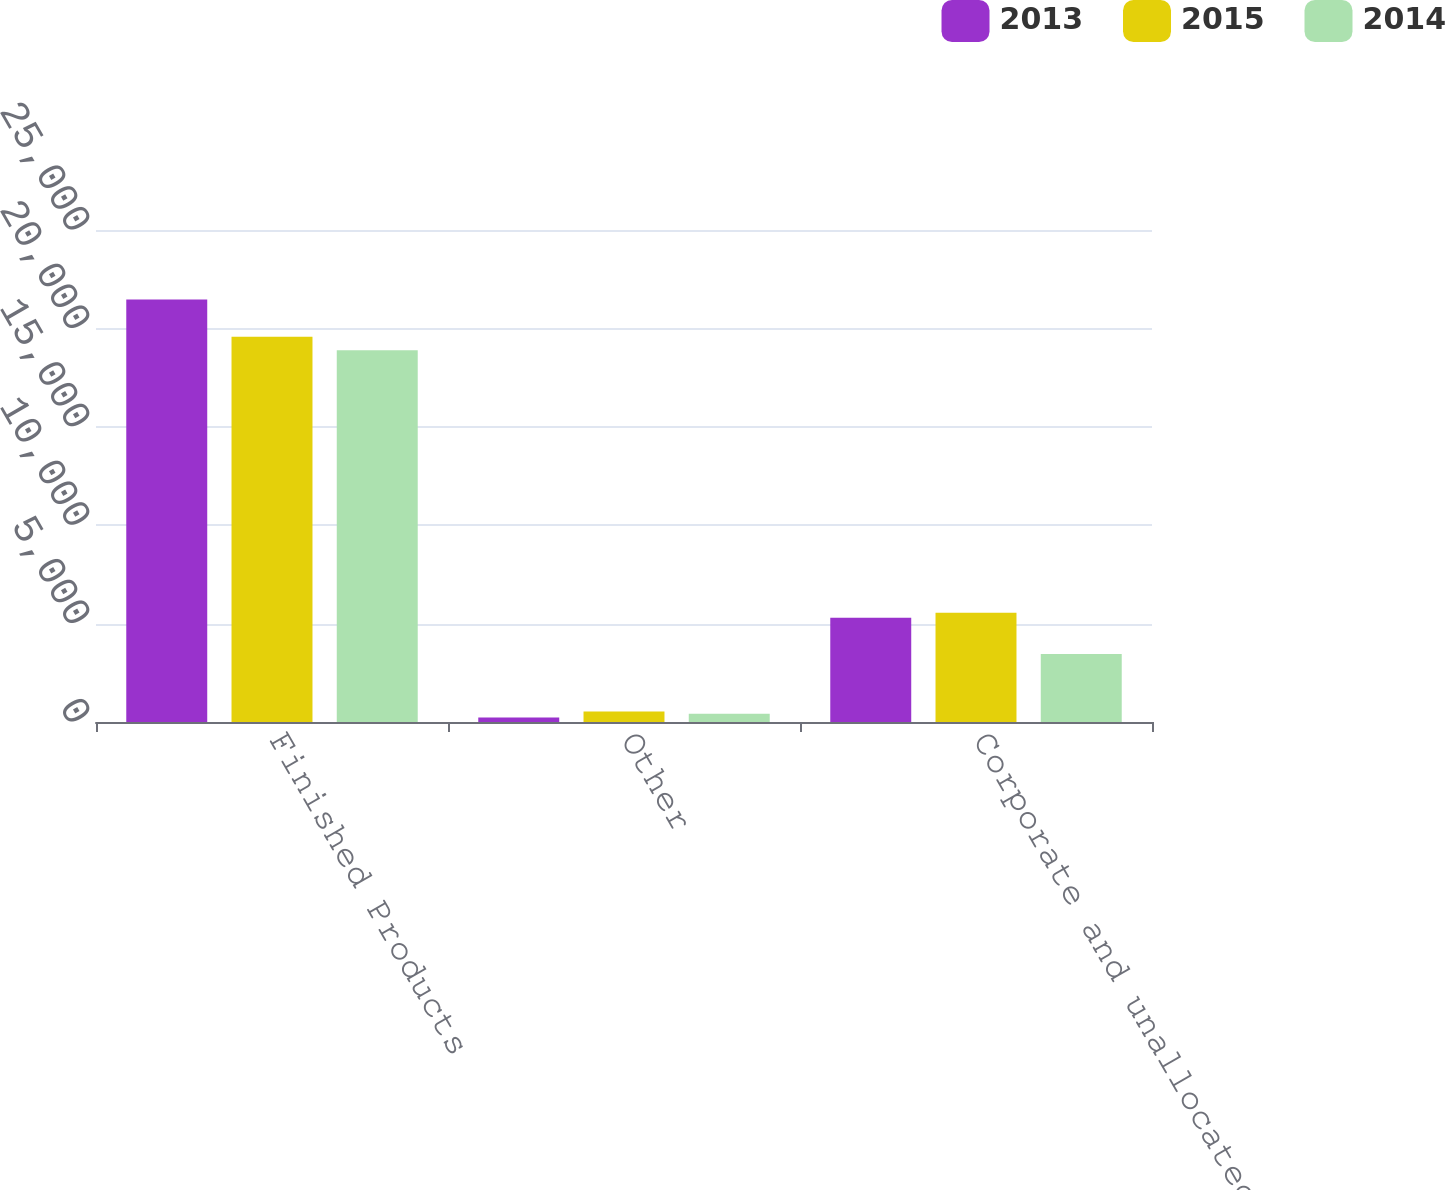Convert chart to OTSL. <chart><loc_0><loc_0><loc_500><loc_500><stacked_bar_chart><ecel><fcel>Finished Products<fcel>Other<fcel>Corporate and unallocated<nl><fcel>2013<fcel>21464<fcel>231<fcel>5297<nl><fcel>2015<fcel>19572<fcel>531<fcel>5548<nl><fcel>2014<fcel>18888<fcel>423<fcel>3451<nl></chart> 